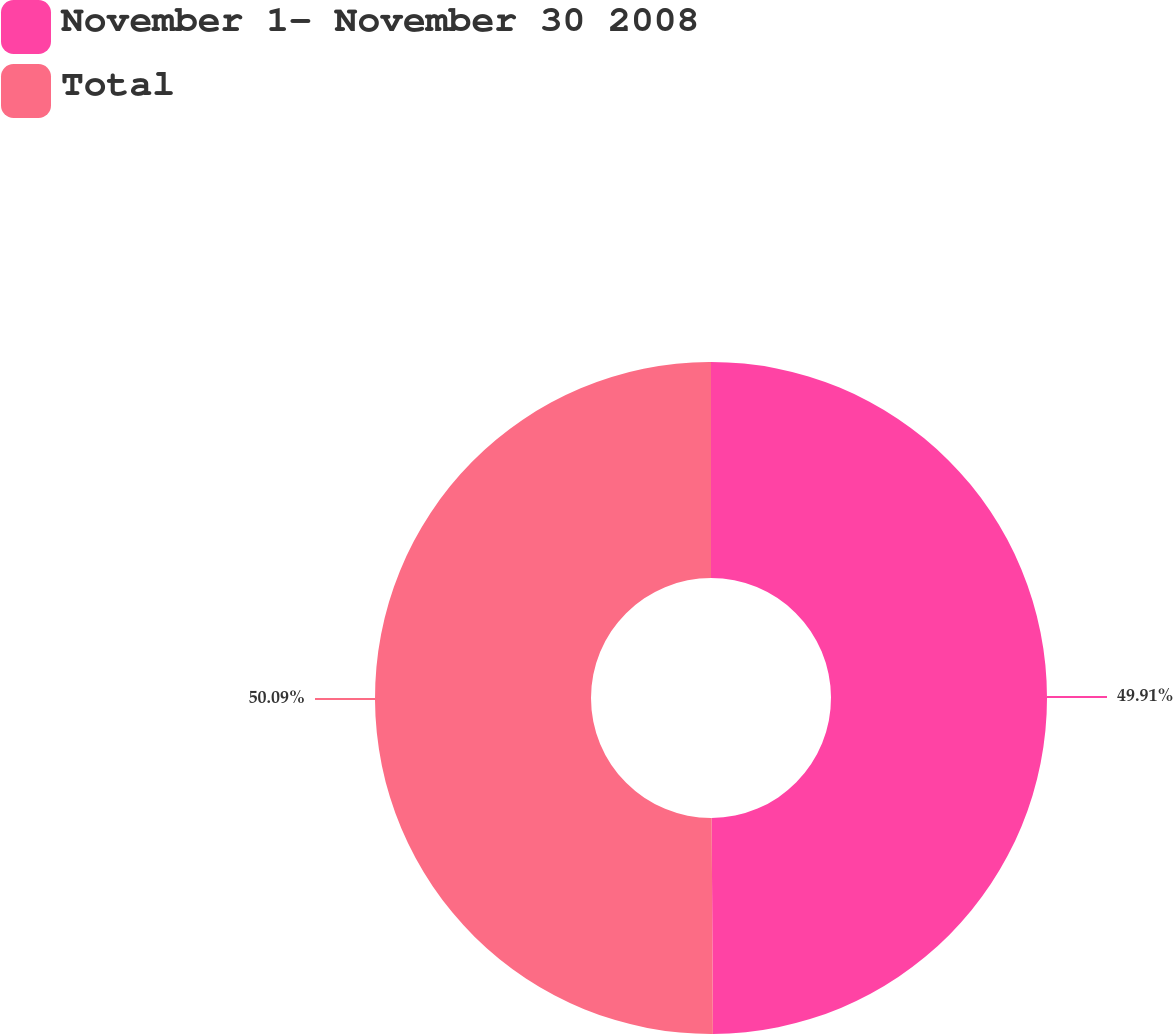<chart> <loc_0><loc_0><loc_500><loc_500><pie_chart><fcel>November 1- November 30 2008<fcel>Total<nl><fcel>49.91%<fcel>50.09%<nl></chart> 